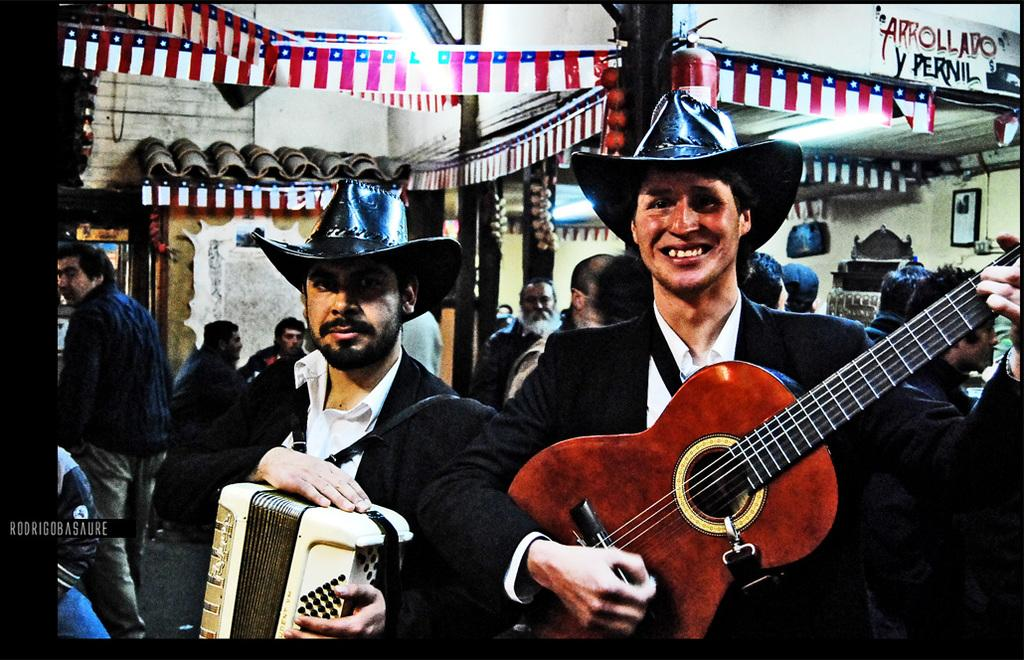How many people are in the image? There are two people in the image. What are the people holding in the image? The two people are holding a guitar and a drum. What are the people wearing in the image? The people are wearing black suits and hats. What type of patch is sewn onto the drum in the image? There is no patch sewn onto the drum in the image; it is a drum without any visible patches. 